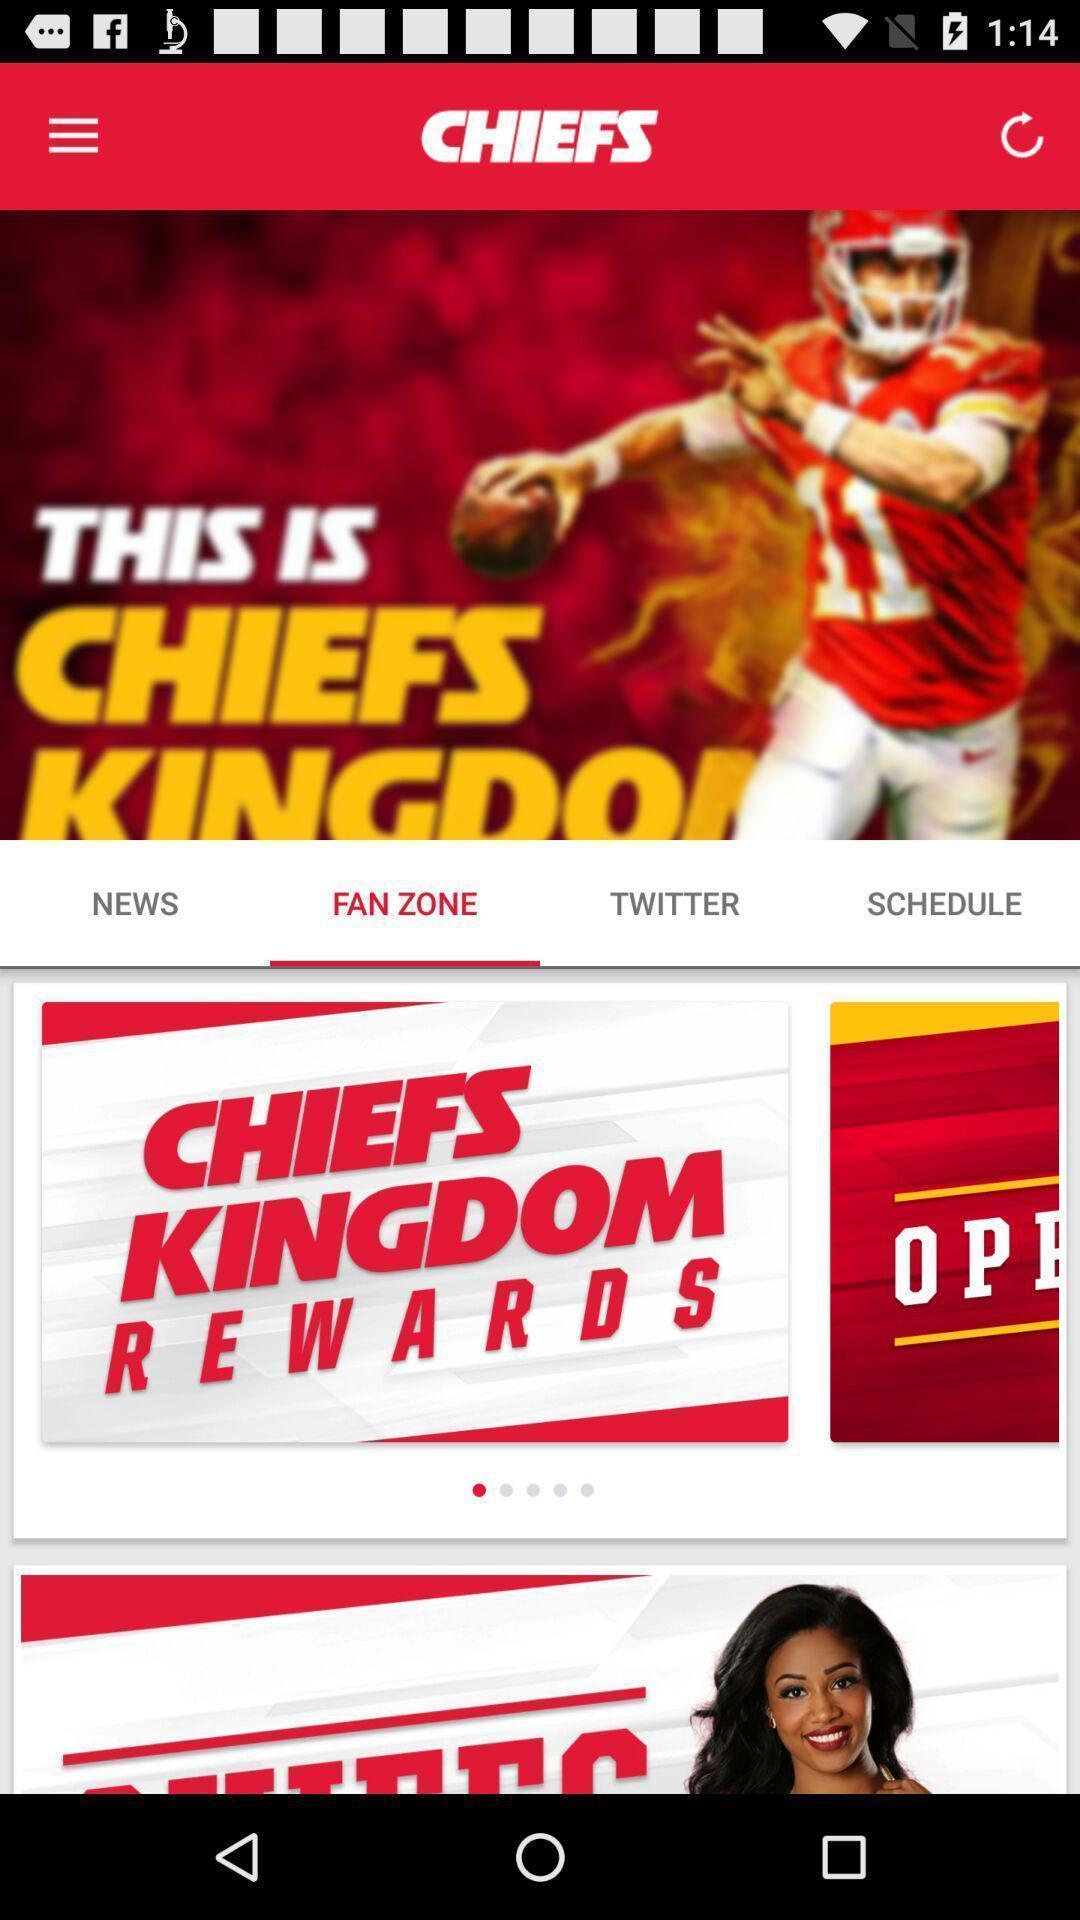Describe this image in words. Screen shows multiple options in a sports application. 